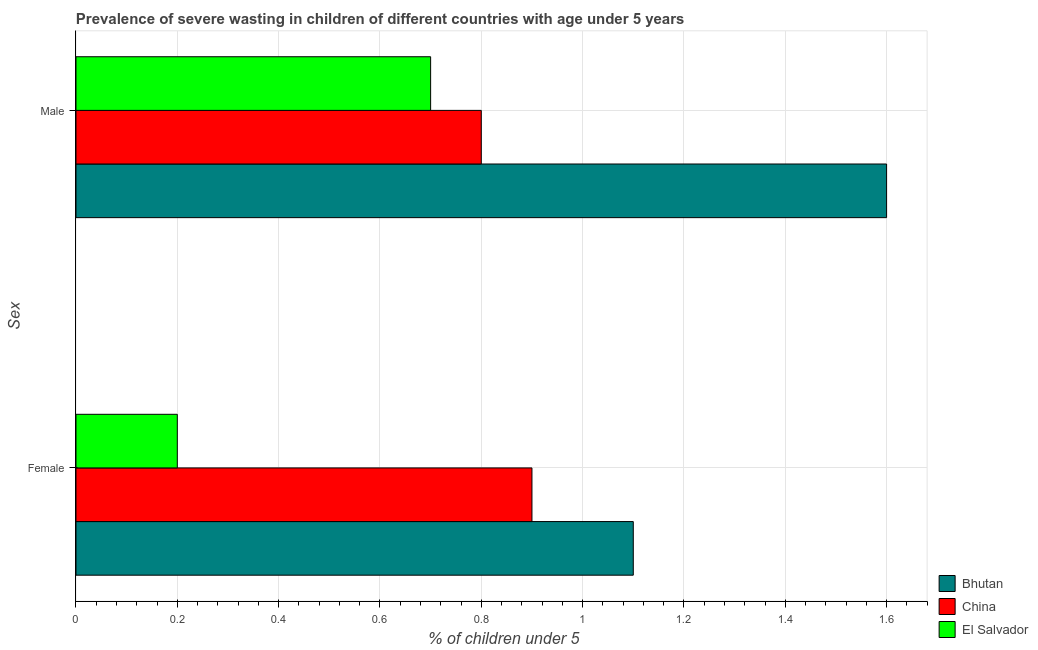How many different coloured bars are there?
Offer a very short reply. 3. How many bars are there on the 2nd tick from the bottom?
Your answer should be compact. 3. What is the label of the 2nd group of bars from the top?
Provide a short and direct response. Female. What is the percentage of undernourished female children in El Salvador?
Offer a very short reply. 0.2. Across all countries, what is the maximum percentage of undernourished female children?
Offer a terse response. 1.1. Across all countries, what is the minimum percentage of undernourished male children?
Your response must be concise. 0.7. In which country was the percentage of undernourished male children maximum?
Give a very brief answer. Bhutan. In which country was the percentage of undernourished male children minimum?
Make the answer very short. El Salvador. What is the total percentage of undernourished female children in the graph?
Your response must be concise. 2.2. What is the difference between the percentage of undernourished female children in Bhutan and that in El Salvador?
Ensure brevity in your answer.  0.9. What is the difference between the percentage of undernourished female children in China and the percentage of undernourished male children in El Salvador?
Make the answer very short. 0.2. What is the average percentage of undernourished male children per country?
Keep it short and to the point. 1.03. What is the difference between the percentage of undernourished female children and percentage of undernourished male children in China?
Provide a short and direct response. 0.1. What is the ratio of the percentage of undernourished male children in Bhutan to that in El Salvador?
Offer a very short reply. 2.29. What does the 3rd bar from the top in Female represents?
Your response must be concise. Bhutan. How many bars are there?
Offer a terse response. 6. What is the difference between two consecutive major ticks on the X-axis?
Your response must be concise. 0.2. Are the values on the major ticks of X-axis written in scientific E-notation?
Offer a very short reply. No. Does the graph contain any zero values?
Give a very brief answer. No. Where does the legend appear in the graph?
Offer a very short reply. Bottom right. How many legend labels are there?
Ensure brevity in your answer.  3. How are the legend labels stacked?
Your answer should be compact. Vertical. What is the title of the graph?
Make the answer very short. Prevalence of severe wasting in children of different countries with age under 5 years. What is the label or title of the X-axis?
Provide a short and direct response.  % of children under 5. What is the label or title of the Y-axis?
Provide a succinct answer. Sex. What is the  % of children under 5 of Bhutan in Female?
Offer a terse response. 1.1. What is the  % of children under 5 of China in Female?
Give a very brief answer. 0.9. What is the  % of children under 5 of El Salvador in Female?
Your answer should be very brief. 0.2. What is the  % of children under 5 in Bhutan in Male?
Your response must be concise. 1.6. What is the  % of children under 5 of China in Male?
Your answer should be compact. 0.8. What is the  % of children under 5 in El Salvador in Male?
Ensure brevity in your answer.  0.7. Across all Sex, what is the maximum  % of children under 5 in Bhutan?
Offer a very short reply. 1.6. Across all Sex, what is the maximum  % of children under 5 in China?
Your answer should be compact. 0.9. Across all Sex, what is the maximum  % of children under 5 in El Salvador?
Provide a short and direct response. 0.7. Across all Sex, what is the minimum  % of children under 5 in Bhutan?
Give a very brief answer. 1.1. Across all Sex, what is the minimum  % of children under 5 in China?
Provide a short and direct response. 0.8. Across all Sex, what is the minimum  % of children under 5 of El Salvador?
Provide a succinct answer. 0.2. What is the total  % of children under 5 in Bhutan in the graph?
Offer a very short reply. 2.7. What is the total  % of children under 5 in China in the graph?
Provide a succinct answer. 1.7. What is the total  % of children under 5 of El Salvador in the graph?
Give a very brief answer. 0.9. What is the difference between the  % of children under 5 of China in Female and that in Male?
Offer a terse response. 0.1. What is the difference between the  % of children under 5 of El Salvador in Female and that in Male?
Your response must be concise. -0.5. What is the difference between the  % of children under 5 in Bhutan in Female and the  % of children under 5 in El Salvador in Male?
Give a very brief answer. 0.4. What is the average  % of children under 5 in Bhutan per Sex?
Provide a succinct answer. 1.35. What is the average  % of children under 5 in El Salvador per Sex?
Offer a terse response. 0.45. What is the difference between the  % of children under 5 in Bhutan and  % of children under 5 in China in Female?
Ensure brevity in your answer.  0.2. What is the difference between the  % of children under 5 of China and  % of children under 5 of El Salvador in Female?
Your answer should be very brief. 0.7. What is the ratio of the  % of children under 5 in Bhutan in Female to that in Male?
Your answer should be compact. 0.69. What is the ratio of the  % of children under 5 in China in Female to that in Male?
Your response must be concise. 1.12. What is the ratio of the  % of children under 5 in El Salvador in Female to that in Male?
Provide a succinct answer. 0.29. What is the difference between the highest and the second highest  % of children under 5 in Bhutan?
Keep it short and to the point. 0.5. What is the difference between the highest and the lowest  % of children under 5 in Bhutan?
Provide a short and direct response. 0.5. What is the difference between the highest and the lowest  % of children under 5 of El Salvador?
Your answer should be compact. 0.5. 